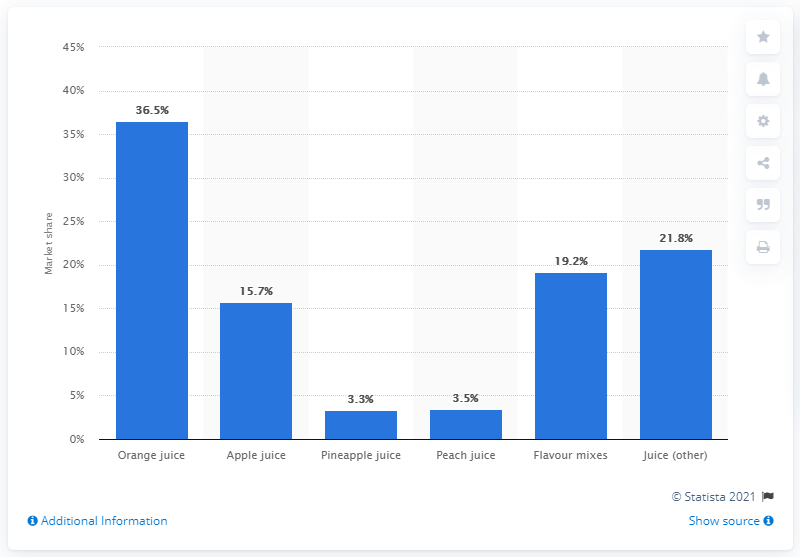Outline some significant characteristics in this image. In 2017, orange juice accounted for 36.5% of total sales. 